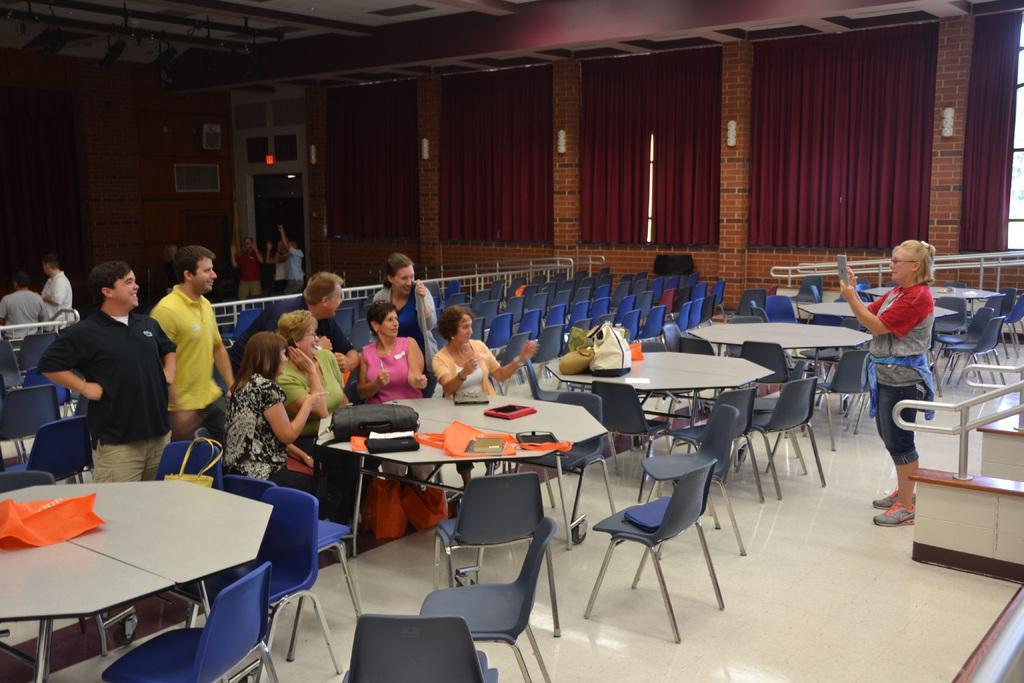Describe this image in one or two sentences. In this image, I can see few people sitting and groups of people standing on the floor. I can see the bags and few other objects on the tables and there are chairs. In the background, I can see the curtains, light and few other objects. At the top of the image, there is a ceiling. 